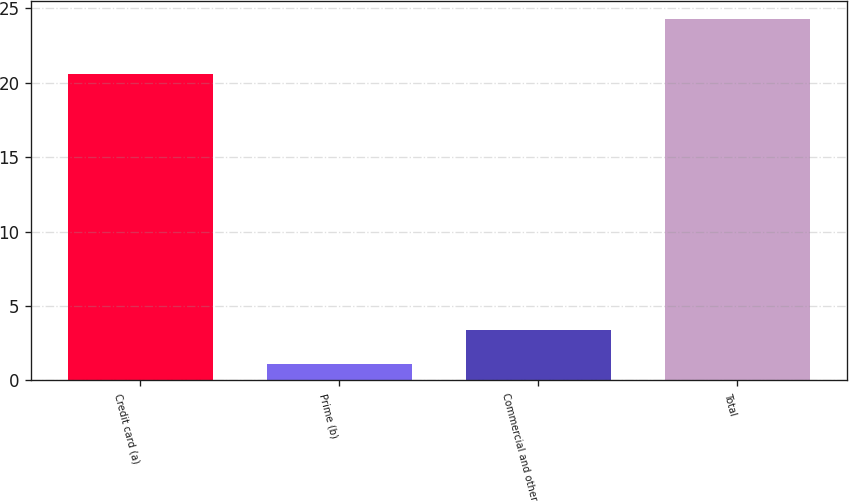Convert chart. <chart><loc_0><loc_0><loc_500><loc_500><bar_chart><fcel>Credit card (a)<fcel>Prime (b)<fcel>Commercial and other<fcel>Total<nl><fcel>20.6<fcel>1.1<fcel>3.42<fcel>24.3<nl></chart> 